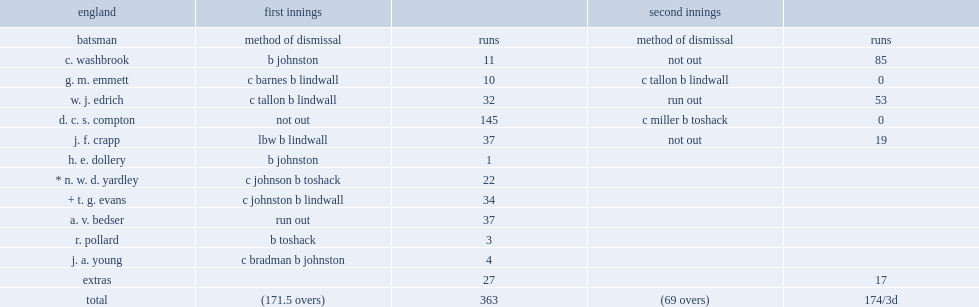In the third test of 1948 ashes series, how many runs was compton unbeaten on? 145.0. 